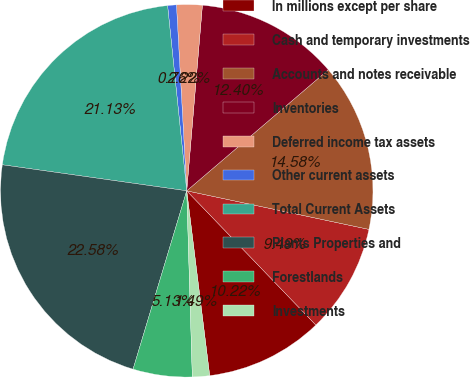Convert chart. <chart><loc_0><loc_0><loc_500><loc_500><pie_chart><fcel>In millions except per share<fcel>Cash and temporary investments<fcel>Accounts and notes receivable<fcel>Inventories<fcel>Deferred income tax assets<fcel>Other current assets<fcel>Total Current Assets<fcel>Plants Properties and<fcel>Forestlands<fcel>Investments<nl><fcel>10.22%<fcel>9.49%<fcel>14.58%<fcel>12.4%<fcel>2.22%<fcel>0.76%<fcel>21.13%<fcel>22.58%<fcel>5.13%<fcel>1.49%<nl></chart> 